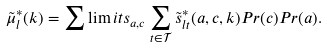Convert formula to latex. <formula><loc_0><loc_0><loc_500><loc_500>\tilde { \mu } _ { l } ^ { * } ( k ) = \sum \lim i t s _ { a , c } \sum _ { t \in \mathcal { T } } \tilde { s } _ { l t } ^ { * } ( a , c , k ) P r ( c ) P r ( a ) .</formula> 